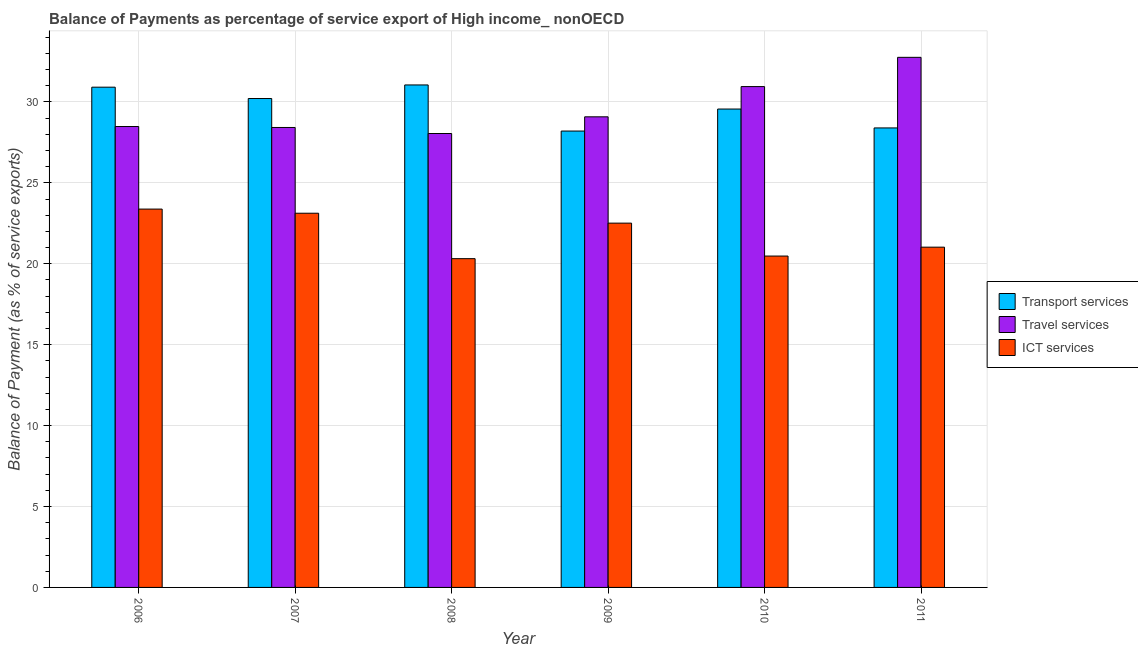Are the number of bars per tick equal to the number of legend labels?
Make the answer very short. Yes. Are the number of bars on each tick of the X-axis equal?
Offer a very short reply. Yes. How many bars are there on the 2nd tick from the left?
Keep it short and to the point. 3. In how many cases, is the number of bars for a given year not equal to the number of legend labels?
Ensure brevity in your answer.  0. What is the balance of payment of ict services in 2006?
Your answer should be compact. 23.38. Across all years, what is the maximum balance of payment of transport services?
Make the answer very short. 31.05. Across all years, what is the minimum balance of payment of ict services?
Give a very brief answer. 20.32. In which year was the balance of payment of ict services minimum?
Your answer should be very brief. 2008. What is the total balance of payment of ict services in the graph?
Keep it short and to the point. 130.84. What is the difference between the balance of payment of transport services in 2008 and that in 2010?
Your response must be concise. 1.49. What is the difference between the balance of payment of ict services in 2006 and the balance of payment of travel services in 2008?
Your answer should be very brief. 3.06. What is the average balance of payment of travel services per year?
Keep it short and to the point. 29.63. What is the ratio of the balance of payment of transport services in 2007 to that in 2009?
Give a very brief answer. 1.07. Is the balance of payment of ict services in 2007 less than that in 2009?
Make the answer very short. No. Is the difference between the balance of payment of ict services in 2006 and 2011 greater than the difference between the balance of payment of transport services in 2006 and 2011?
Offer a very short reply. No. What is the difference between the highest and the second highest balance of payment of transport services?
Make the answer very short. 0.14. What is the difference between the highest and the lowest balance of payment of ict services?
Keep it short and to the point. 3.06. In how many years, is the balance of payment of ict services greater than the average balance of payment of ict services taken over all years?
Keep it short and to the point. 3. What does the 1st bar from the left in 2006 represents?
Offer a very short reply. Transport services. What does the 1st bar from the right in 2006 represents?
Your response must be concise. ICT services. Is it the case that in every year, the sum of the balance of payment of transport services and balance of payment of travel services is greater than the balance of payment of ict services?
Provide a short and direct response. Yes. How many years are there in the graph?
Your answer should be very brief. 6. What is the difference between two consecutive major ticks on the Y-axis?
Make the answer very short. 5. Are the values on the major ticks of Y-axis written in scientific E-notation?
Ensure brevity in your answer.  No. How are the legend labels stacked?
Your response must be concise. Vertical. What is the title of the graph?
Provide a short and direct response. Balance of Payments as percentage of service export of High income_ nonOECD. What is the label or title of the X-axis?
Ensure brevity in your answer.  Year. What is the label or title of the Y-axis?
Offer a terse response. Balance of Payment (as % of service exports). What is the Balance of Payment (as % of service exports) in Transport services in 2006?
Offer a terse response. 30.91. What is the Balance of Payment (as % of service exports) in Travel services in 2006?
Your answer should be compact. 28.48. What is the Balance of Payment (as % of service exports) in ICT services in 2006?
Offer a terse response. 23.38. What is the Balance of Payment (as % of service exports) in Transport services in 2007?
Make the answer very short. 30.21. What is the Balance of Payment (as % of service exports) of Travel services in 2007?
Your response must be concise. 28.42. What is the Balance of Payment (as % of service exports) in ICT services in 2007?
Your response must be concise. 23.12. What is the Balance of Payment (as % of service exports) in Transport services in 2008?
Your answer should be very brief. 31.05. What is the Balance of Payment (as % of service exports) in Travel services in 2008?
Your response must be concise. 28.05. What is the Balance of Payment (as % of service exports) of ICT services in 2008?
Keep it short and to the point. 20.32. What is the Balance of Payment (as % of service exports) of Transport services in 2009?
Make the answer very short. 28.2. What is the Balance of Payment (as % of service exports) of Travel services in 2009?
Provide a short and direct response. 29.08. What is the Balance of Payment (as % of service exports) in ICT services in 2009?
Ensure brevity in your answer.  22.51. What is the Balance of Payment (as % of service exports) in Transport services in 2010?
Your answer should be compact. 29.56. What is the Balance of Payment (as % of service exports) of Travel services in 2010?
Offer a very short reply. 30.95. What is the Balance of Payment (as % of service exports) of ICT services in 2010?
Your response must be concise. 20.48. What is the Balance of Payment (as % of service exports) of Transport services in 2011?
Offer a very short reply. 28.4. What is the Balance of Payment (as % of service exports) of Travel services in 2011?
Provide a succinct answer. 32.76. What is the Balance of Payment (as % of service exports) of ICT services in 2011?
Provide a short and direct response. 21.03. Across all years, what is the maximum Balance of Payment (as % of service exports) of Transport services?
Provide a succinct answer. 31.05. Across all years, what is the maximum Balance of Payment (as % of service exports) of Travel services?
Ensure brevity in your answer.  32.76. Across all years, what is the maximum Balance of Payment (as % of service exports) of ICT services?
Give a very brief answer. 23.38. Across all years, what is the minimum Balance of Payment (as % of service exports) in Transport services?
Keep it short and to the point. 28.2. Across all years, what is the minimum Balance of Payment (as % of service exports) in Travel services?
Keep it short and to the point. 28.05. Across all years, what is the minimum Balance of Payment (as % of service exports) in ICT services?
Provide a succinct answer. 20.32. What is the total Balance of Payment (as % of service exports) in Transport services in the graph?
Provide a short and direct response. 178.34. What is the total Balance of Payment (as % of service exports) in Travel services in the graph?
Your answer should be very brief. 177.75. What is the total Balance of Payment (as % of service exports) of ICT services in the graph?
Give a very brief answer. 130.84. What is the difference between the Balance of Payment (as % of service exports) of Transport services in 2006 and that in 2007?
Offer a terse response. 0.7. What is the difference between the Balance of Payment (as % of service exports) in Travel services in 2006 and that in 2007?
Keep it short and to the point. 0.06. What is the difference between the Balance of Payment (as % of service exports) in ICT services in 2006 and that in 2007?
Ensure brevity in your answer.  0.26. What is the difference between the Balance of Payment (as % of service exports) of Transport services in 2006 and that in 2008?
Give a very brief answer. -0.14. What is the difference between the Balance of Payment (as % of service exports) of Travel services in 2006 and that in 2008?
Your response must be concise. 0.43. What is the difference between the Balance of Payment (as % of service exports) of ICT services in 2006 and that in 2008?
Keep it short and to the point. 3.06. What is the difference between the Balance of Payment (as % of service exports) in Transport services in 2006 and that in 2009?
Provide a short and direct response. 2.71. What is the difference between the Balance of Payment (as % of service exports) in Travel services in 2006 and that in 2009?
Provide a succinct answer. -0.6. What is the difference between the Balance of Payment (as % of service exports) of ICT services in 2006 and that in 2009?
Provide a succinct answer. 0.87. What is the difference between the Balance of Payment (as % of service exports) in Transport services in 2006 and that in 2010?
Ensure brevity in your answer.  1.35. What is the difference between the Balance of Payment (as % of service exports) in Travel services in 2006 and that in 2010?
Provide a succinct answer. -2.47. What is the difference between the Balance of Payment (as % of service exports) in ICT services in 2006 and that in 2010?
Ensure brevity in your answer.  2.9. What is the difference between the Balance of Payment (as % of service exports) in Transport services in 2006 and that in 2011?
Keep it short and to the point. 2.52. What is the difference between the Balance of Payment (as % of service exports) of Travel services in 2006 and that in 2011?
Your answer should be very brief. -4.28. What is the difference between the Balance of Payment (as % of service exports) in ICT services in 2006 and that in 2011?
Your response must be concise. 2.35. What is the difference between the Balance of Payment (as % of service exports) in Transport services in 2007 and that in 2008?
Offer a terse response. -0.84. What is the difference between the Balance of Payment (as % of service exports) in Travel services in 2007 and that in 2008?
Ensure brevity in your answer.  0.37. What is the difference between the Balance of Payment (as % of service exports) of ICT services in 2007 and that in 2008?
Give a very brief answer. 2.81. What is the difference between the Balance of Payment (as % of service exports) in Transport services in 2007 and that in 2009?
Ensure brevity in your answer.  2.01. What is the difference between the Balance of Payment (as % of service exports) in Travel services in 2007 and that in 2009?
Offer a very short reply. -0.66. What is the difference between the Balance of Payment (as % of service exports) of ICT services in 2007 and that in 2009?
Make the answer very short. 0.61. What is the difference between the Balance of Payment (as % of service exports) of Transport services in 2007 and that in 2010?
Your answer should be very brief. 0.65. What is the difference between the Balance of Payment (as % of service exports) in Travel services in 2007 and that in 2010?
Your answer should be compact. -2.53. What is the difference between the Balance of Payment (as % of service exports) of ICT services in 2007 and that in 2010?
Provide a short and direct response. 2.65. What is the difference between the Balance of Payment (as % of service exports) in Transport services in 2007 and that in 2011?
Provide a succinct answer. 1.82. What is the difference between the Balance of Payment (as % of service exports) of Travel services in 2007 and that in 2011?
Your answer should be compact. -4.33. What is the difference between the Balance of Payment (as % of service exports) in ICT services in 2007 and that in 2011?
Your response must be concise. 2.1. What is the difference between the Balance of Payment (as % of service exports) in Transport services in 2008 and that in 2009?
Provide a succinct answer. 2.85. What is the difference between the Balance of Payment (as % of service exports) in Travel services in 2008 and that in 2009?
Keep it short and to the point. -1.03. What is the difference between the Balance of Payment (as % of service exports) of ICT services in 2008 and that in 2009?
Your answer should be very brief. -2.2. What is the difference between the Balance of Payment (as % of service exports) in Transport services in 2008 and that in 2010?
Offer a very short reply. 1.49. What is the difference between the Balance of Payment (as % of service exports) of Travel services in 2008 and that in 2010?
Offer a terse response. -2.9. What is the difference between the Balance of Payment (as % of service exports) of ICT services in 2008 and that in 2010?
Offer a very short reply. -0.16. What is the difference between the Balance of Payment (as % of service exports) of Transport services in 2008 and that in 2011?
Your answer should be very brief. 2.66. What is the difference between the Balance of Payment (as % of service exports) in Travel services in 2008 and that in 2011?
Give a very brief answer. -4.71. What is the difference between the Balance of Payment (as % of service exports) in ICT services in 2008 and that in 2011?
Provide a short and direct response. -0.71. What is the difference between the Balance of Payment (as % of service exports) in Transport services in 2009 and that in 2010?
Offer a very short reply. -1.36. What is the difference between the Balance of Payment (as % of service exports) of Travel services in 2009 and that in 2010?
Give a very brief answer. -1.87. What is the difference between the Balance of Payment (as % of service exports) in ICT services in 2009 and that in 2010?
Keep it short and to the point. 2.03. What is the difference between the Balance of Payment (as % of service exports) in Transport services in 2009 and that in 2011?
Your answer should be compact. -0.19. What is the difference between the Balance of Payment (as % of service exports) in Travel services in 2009 and that in 2011?
Offer a very short reply. -3.68. What is the difference between the Balance of Payment (as % of service exports) in ICT services in 2009 and that in 2011?
Provide a succinct answer. 1.48. What is the difference between the Balance of Payment (as % of service exports) in Transport services in 2010 and that in 2011?
Your answer should be compact. 1.17. What is the difference between the Balance of Payment (as % of service exports) in Travel services in 2010 and that in 2011?
Your answer should be compact. -1.81. What is the difference between the Balance of Payment (as % of service exports) of ICT services in 2010 and that in 2011?
Keep it short and to the point. -0.55. What is the difference between the Balance of Payment (as % of service exports) of Transport services in 2006 and the Balance of Payment (as % of service exports) of Travel services in 2007?
Offer a terse response. 2.49. What is the difference between the Balance of Payment (as % of service exports) of Transport services in 2006 and the Balance of Payment (as % of service exports) of ICT services in 2007?
Provide a succinct answer. 7.79. What is the difference between the Balance of Payment (as % of service exports) in Travel services in 2006 and the Balance of Payment (as % of service exports) in ICT services in 2007?
Your answer should be compact. 5.36. What is the difference between the Balance of Payment (as % of service exports) in Transport services in 2006 and the Balance of Payment (as % of service exports) in Travel services in 2008?
Your response must be concise. 2.86. What is the difference between the Balance of Payment (as % of service exports) in Transport services in 2006 and the Balance of Payment (as % of service exports) in ICT services in 2008?
Give a very brief answer. 10.6. What is the difference between the Balance of Payment (as % of service exports) of Travel services in 2006 and the Balance of Payment (as % of service exports) of ICT services in 2008?
Provide a short and direct response. 8.17. What is the difference between the Balance of Payment (as % of service exports) in Transport services in 2006 and the Balance of Payment (as % of service exports) in Travel services in 2009?
Offer a terse response. 1.83. What is the difference between the Balance of Payment (as % of service exports) in Transport services in 2006 and the Balance of Payment (as % of service exports) in ICT services in 2009?
Your answer should be compact. 8.4. What is the difference between the Balance of Payment (as % of service exports) in Travel services in 2006 and the Balance of Payment (as % of service exports) in ICT services in 2009?
Your response must be concise. 5.97. What is the difference between the Balance of Payment (as % of service exports) in Transport services in 2006 and the Balance of Payment (as % of service exports) in Travel services in 2010?
Your answer should be very brief. -0.04. What is the difference between the Balance of Payment (as % of service exports) of Transport services in 2006 and the Balance of Payment (as % of service exports) of ICT services in 2010?
Your answer should be very brief. 10.44. What is the difference between the Balance of Payment (as % of service exports) of Travel services in 2006 and the Balance of Payment (as % of service exports) of ICT services in 2010?
Provide a succinct answer. 8. What is the difference between the Balance of Payment (as % of service exports) of Transport services in 2006 and the Balance of Payment (as % of service exports) of Travel services in 2011?
Your answer should be compact. -1.84. What is the difference between the Balance of Payment (as % of service exports) in Transport services in 2006 and the Balance of Payment (as % of service exports) in ICT services in 2011?
Provide a succinct answer. 9.89. What is the difference between the Balance of Payment (as % of service exports) of Travel services in 2006 and the Balance of Payment (as % of service exports) of ICT services in 2011?
Offer a very short reply. 7.46. What is the difference between the Balance of Payment (as % of service exports) in Transport services in 2007 and the Balance of Payment (as % of service exports) in Travel services in 2008?
Your answer should be very brief. 2.16. What is the difference between the Balance of Payment (as % of service exports) of Transport services in 2007 and the Balance of Payment (as % of service exports) of ICT services in 2008?
Your answer should be compact. 9.9. What is the difference between the Balance of Payment (as % of service exports) of Travel services in 2007 and the Balance of Payment (as % of service exports) of ICT services in 2008?
Keep it short and to the point. 8.11. What is the difference between the Balance of Payment (as % of service exports) in Transport services in 2007 and the Balance of Payment (as % of service exports) in Travel services in 2009?
Give a very brief answer. 1.13. What is the difference between the Balance of Payment (as % of service exports) of Transport services in 2007 and the Balance of Payment (as % of service exports) of ICT services in 2009?
Offer a terse response. 7.7. What is the difference between the Balance of Payment (as % of service exports) in Travel services in 2007 and the Balance of Payment (as % of service exports) in ICT services in 2009?
Your answer should be very brief. 5.91. What is the difference between the Balance of Payment (as % of service exports) of Transport services in 2007 and the Balance of Payment (as % of service exports) of Travel services in 2010?
Provide a succinct answer. -0.74. What is the difference between the Balance of Payment (as % of service exports) in Transport services in 2007 and the Balance of Payment (as % of service exports) in ICT services in 2010?
Make the answer very short. 9.74. What is the difference between the Balance of Payment (as % of service exports) in Travel services in 2007 and the Balance of Payment (as % of service exports) in ICT services in 2010?
Provide a succinct answer. 7.95. What is the difference between the Balance of Payment (as % of service exports) of Transport services in 2007 and the Balance of Payment (as % of service exports) of Travel services in 2011?
Offer a terse response. -2.55. What is the difference between the Balance of Payment (as % of service exports) in Transport services in 2007 and the Balance of Payment (as % of service exports) in ICT services in 2011?
Your answer should be compact. 9.19. What is the difference between the Balance of Payment (as % of service exports) of Travel services in 2007 and the Balance of Payment (as % of service exports) of ICT services in 2011?
Offer a terse response. 7.4. What is the difference between the Balance of Payment (as % of service exports) of Transport services in 2008 and the Balance of Payment (as % of service exports) of Travel services in 2009?
Keep it short and to the point. 1.97. What is the difference between the Balance of Payment (as % of service exports) of Transport services in 2008 and the Balance of Payment (as % of service exports) of ICT services in 2009?
Offer a very short reply. 8.54. What is the difference between the Balance of Payment (as % of service exports) of Travel services in 2008 and the Balance of Payment (as % of service exports) of ICT services in 2009?
Your answer should be very brief. 5.54. What is the difference between the Balance of Payment (as % of service exports) of Transport services in 2008 and the Balance of Payment (as % of service exports) of Travel services in 2010?
Keep it short and to the point. 0.1. What is the difference between the Balance of Payment (as % of service exports) of Transport services in 2008 and the Balance of Payment (as % of service exports) of ICT services in 2010?
Offer a very short reply. 10.57. What is the difference between the Balance of Payment (as % of service exports) in Travel services in 2008 and the Balance of Payment (as % of service exports) in ICT services in 2010?
Your answer should be compact. 7.57. What is the difference between the Balance of Payment (as % of service exports) of Transport services in 2008 and the Balance of Payment (as % of service exports) of Travel services in 2011?
Your response must be concise. -1.71. What is the difference between the Balance of Payment (as % of service exports) in Transport services in 2008 and the Balance of Payment (as % of service exports) in ICT services in 2011?
Keep it short and to the point. 10.02. What is the difference between the Balance of Payment (as % of service exports) of Travel services in 2008 and the Balance of Payment (as % of service exports) of ICT services in 2011?
Keep it short and to the point. 7.02. What is the difference between the Balance of Payment (as % of service exports) in Transport services in 2009 and the Balance of Payment (as % of service exports) in Travel services in 2010?
Offer a very short reply. -2.75. What is the difference between the Balance of Payment (as % of service exports) of Transport services in 2009 and the Balance of Payment (as % of service exports) of ICT services in 2010?
Your response must be concise. 7.72. What is the difference between the Balance of Payment (as % of service exports) of Travel services in 2009 and the Balance of Payment (as % of service exports) of ICT services in 2010?
Your answer should be compact. 8.6. What is the difference between the Balance of Payment (as % of service exports) of Transport services in 2009 and the Balance of Payment (as % of service exports) of Travel services in 2011?
Keep it short and to the point. -4.56. What is the difference between the Balance of Payment (as % of service exports) in Transport services in 2009 and the Balance of Payment (as % of service exports) in ICT services in 2011?
Provide a short and direct response. 7.18. What is the difference between the Balance of Payment (as % of service exports) of Travel services in 2009 and the Balance of Payment (as % of service exports) of ICT services in 2011?
Offer a terse response. 8.06. What is the difference between the Balance of Payment (as % of service exports) in Transport services in 2010 and the Balance of Payment (as % of service exports) in Travel services in 2011?
Your response must be concise. -3.2. What is the difference between the Balance of Payment (as % of service exports) of Transport services in 2010 and the Balance of Payment (as % of service exports) of ICT services in 2011?
Give a very brief answer. 8.54. What is the difference between the Balance of Payment (as % of service exports) in Travel services in 2010 and the Balance of Payment (as % of service exports) in ICT services in 2011?
Your response must be concise. 9.92. What is the average Balance of Payment (as % of service exports) of Transport services per year?
Your answer should be compact. 29.72. What is the average Balance of Payment (as % of service exports) in Travel services per year?
Offer a very short reply. 29.63. What is the average Balance of Payment (as % of service exports) of ICT services per year?
Your answer should be compact. 21.81. In the year 2006, what is the difference between the Balance of Payment (as % of service exports) of Transport services and Balance of Payment (as % of service exports) of Travel services?
Provide a succinct answer. 2.43. In the year 2006, what is the difference between the Balance of Payment (as % of service exports) in Transport services and Balance of Payment (as % of service exports) in ICT services?
Provide a succinct answer. 7.53. In the year 2006, what is the difference between the Balance of Payment (as % of service exports) in Travel services and Balance of Payment (as % of service exports) in ICT services?
Ensure brevity in your answer.  5.1. In the year 2007, what is the difference between the Balance of Payment (as % of service exports) of Transport services and Balance of Payment (as % of service exports) of Travel services?
Your answer should be very brief. 1.79. In the year 2007, what is the difference between the Balance of Payment (as % of service exports) in Transport services and Balance of Payment (as % of service exports) in ICT services?
Provide a short and direct response. 7.09. In the year 2007, what is the difference between the Balance of Payment (as % of service exports) of Travel services and Balance of Payment (as % of service exports) of ICT services?
Make the answer very short. 5.3. In the year 2008, what is the difference between the Balance of Payment (as % of service exports) in Transport services and Balance of Payment (as % of service exports) in Travel services?
Provide a short and direct response. 3. In the year 2008, what is the difference between the Balance of Payment (as % of service exports) of Transport services and Balance of Payment (as % of service exports) of ICT services?
Keep it short and to the point. 10.73. In the year 2008, what is the difference between the Balance of Payment (as % of service exports) in Travel services and Balance of Payment (as % of service exports) in ICT services?
Your answer should be very brief. 7.73. In the year 2009, what is the difference between the Balance of Payment (as % of service exports) in Transport services and Balance of Payment (as % of service exports) in Travel services?
Provide a short and direct response. -0.88. In the year 2009, what is the difference between the Balance of Payment (as % of service exports) of Transport services and Balance of Payment (as % of service exports) of ICT services?
Provide a short and direct response. 5.69. In the year 2009, what is the difference between the Balance of Payment (as % of service exports) of Travel services and Balance of Payment (as % of service exports) of ICT services?
Give a very brief answer. 6.57. In the year 2010, what is the difference between the Balance of Payment (as % of service exports) in Transport services and Balance of Payment (as % of service exports) in Travel services?
Ensure brevity in your answer.  -1.39. In the year 2010, what is the difference between the Balance of Payment (as % of service exports) of Transport services and Balance of Payment (as % of service exports) of ICT services?
Offer a very short reply. 9.09. In the year 2010, what is the difference between the Balance of Payment (as % of service exports) in Travel services and Balance of Payment (as % of service exports) in ICT services?
Make the answer very short. 10.47. In the year 2011, what is the difference between the Balance of Payment (as % of service exports) in Transport services and Balance of Payment (as % of service exports) in Travel services?
Give a very brief answer. -4.36. In the year 2011, what is the difference between the Balance of Payment (as % of service exports) of Transport services and Balance of Payment (as % of service exports) of ICT services?
Your answer should be compact. 7.37. In the year 2011, what is the difference between the Balance of Payment (as % of service exports) in Travel services and Balance of Payment (as % of service exports) in ICT services?
Your response must be concise. 11.73. What is the ratio of the Balance of Payment (as % of service exports) of Transport services in 2006 to that in 2007?
Offer a terse response. 1.02. What is the ratio of the Balance of Payment (as % of service exports) of Travel services in 2006 to that in 2007?
Offer a terse response. 1. What is the ratio of the Balance of Payment (as % of service exports) of ICT services in 2006 to that in 2007?
Offer a very short reply. 1.01. What is the ratio of the Balance of Payment (as % of service exports) in Transport services in 2006 to that in 2008?
Your answer should be very brief. 1. What is the ratio of the Balance of Payment (as % of service exports) of Travel services in 2006 to that in 2008?
Offer a terse response. 1.02. What is the ratio of the Balance of Payment (as % of service exports) in ICT services in 2006 to that in 2008?
Give a very brief answer. 1.15. What is the ratio of the Balance of Payment (as % of service exports) of Transport services in 2006 to that in 2009?
Make the answer very short. 1.1. What is the ratio of the Balance of Payment (as % of service exports) of Travel services in 2006 to that in 2009?
Your answer should be compact. 0.98. What is the ratio of the Balance of Payment (as % of service exports) in ICT services in 2006 to that in 2009?
Offer a terse response. 1.04. What is the ratio of the Balance of Payment (as % of service exports) of Transport services in 2006 to that in 2010?
Ensure brevity in your answer.  1.05. What is the ratio of the Balance of Payment (as % of service exports) of Travel services in 2006 to that in 2010?
Provide a short and direct response. 0.92. What is the ratio of the Balance of Payment (as % of service exports) of ICT services in 2006 to that in 2010?
Give a very brief answer. 1.14. What is the ratio of the Balance of Payment (as % of service exports) of Transport services in 2006 to that in 2011?
Give a very brief answer. 1.09. What is the ratio of the Balance of Payment (as % of service exports) in Travel services in 2006 to that in 2011?
Ensure brevity in your answer.  0.87. What is the ratio of the Balance of Payment (as % of service exports) of ICT services in 2006 to that in 2011?
Your response must be concise. 1.11. What is the ratio of the Balance of Payment (as % of service exports) in Travel services in 2007 to that in 2008?
Make the answer very short. 1.01. What is the ratio of the Balance of Payment (as % of service exports) of ICT services in 2007 to that in 2008?
Make the answer very short. 1.14. What is the ratio of the Balance of Payment (as % of service exports) of Transport services in 2007 to that in 2009?
Your answer should be very brief. 1.07. What is the ratio of the Balance of Payment (as % of service exports) of Travel services in 2007 to that in 2009?
Provide a succinct answer. 0.98. What is the ratio of the Balance of Payment (as % of service exports) in ICT services in 2007 to that in 2009?
Keep it short and to the point. 1.03. What is the ratio of the Balance of Payment (as % of service exports) of Transport services in 2007 to that in 2010?
Give a very brief answer. 1.02. What is the ratio of the Balance of Payment (as % of service exports) in Travel services in 2007 to that in 2010?
Ensure brevity in your answer.  0.92. What is the ratio of the Balance of Payment (as % of service exports) of ICT services in 2007 to that in 2010?
Provide a short and direct response. 1.13. What is the ratio of the Balance of Payment (as % of service exports) in Transport services in 2007 to that in 2011?
Make the answer very short. 1.06. What is the ratio of the Balance of Payment (as % of service exports) in Travel services in 2007 to that in 2011?
Keep it short and to the point. 0.87. What is the ratio of the Balance of Payment (as % of service exports) of ICT services in 2007 to that in 2011?
Offer a very short reply. 1.1. What is the ratio of the Balance of Payment (as % of service exports) in Transport services in 2008 to that in 2009?
Keep it short and to the point. 1.1. What is the ratio of the Balance of Payment (as % of service exports) in Travel services in 2008 to that in 2009?
Your answer should be compact. 0.96. What is the ratio of the Balance of Payment (as % of service exports) of ICT services in 2008 to that in 2009?
Ensure brevity in your answer.  0.9. What is the ratio of the Balance of Payment (as % of service exports) in Transport services in 2008 to that in 2010?
Offer a terse response. 1.05. What is the ratio of the Balance of Payment (as % of service exports) of Travel services in 2008 to that in 2010?
Keep it short and to the point. 0.91. What is the ratio of the Balance of Payment (as % of service exports) in Transport services in 2008 to that in 2011?
Your answer should be compact. 1.09. What is the ratio of the Balance of Payment (as % of service exports) of Travel services in 2008 to that in 2011?
Offer a terse response. 0.86. What is the ratio of the Balance of Payment (as % of service exports) of ICT services in 2008 to that in 2011?
Offer a very short reply. 0.97. What is the ratio of the Balance of Payment (as % of service exports) of Transport services in 2009 to that in 2010?
Offer a very short reply. 0.95. What is the ratio of the Balance of Payment (as % of service exports) of Travel services in 2009 to that in 2010?
Provide a succinct answer. 0.94. What is the ratio of the Balance of Payment (as % of service exports) of ICT services in 2009 to that in 2010?
Provide a short and direct response. 1.1. What is the ratio of the Balance of Payment (as % of service exports) of Travel services in 2009 to that in 2011?
Keep it short and to the point. 0.89. What is the ratio of the Balance of Payment (as % of service exports) of ICT services in 2009 to that in 2011?
Provide a short and direct response. 1.07. What is the ratio of the Balance of Payment (as % of service exports) of Transport services in 2010 to that in 2011?
Your response must be concise. 1.04. What is the ratio of the Balance of Payment (as % of service exports) in Travel services in 2010 to that in 2011?
Your answer should be compact. 0.94. What is the ratio of the Balance of Payment (as % of service exports) in ICT services in 2010 to that in 2011?
Keep it short and to the point. 0.97. What is the difference between the highest and the second highest Balance of Payment (as % of service exports) of Transport services?
Your answer should be compact. 0.14. What is the difference between the highest and the second highest Balance of Payment (as % of service exports) in Travel services?
Offer a very short reply. 1.81. What is the difference between the highest and the second highest Balance of Payment (as % of service exports) of ICT services?
Keep it short and to the point. 0.26. What is the difference between the highest and the lowest Balance of Payment (as % of service exports) in Transport services?
Give a very brief answer. 2.85. What is the difference between the highest and the lowest Balance of Payment (as % of service exports) in Travel services?
Provide a short and direct response. 4.71. What is the difference between the highest and the lowest Balance of Payment (as % of service exports) in ICT services?
Offer a terse response. 3.06. 